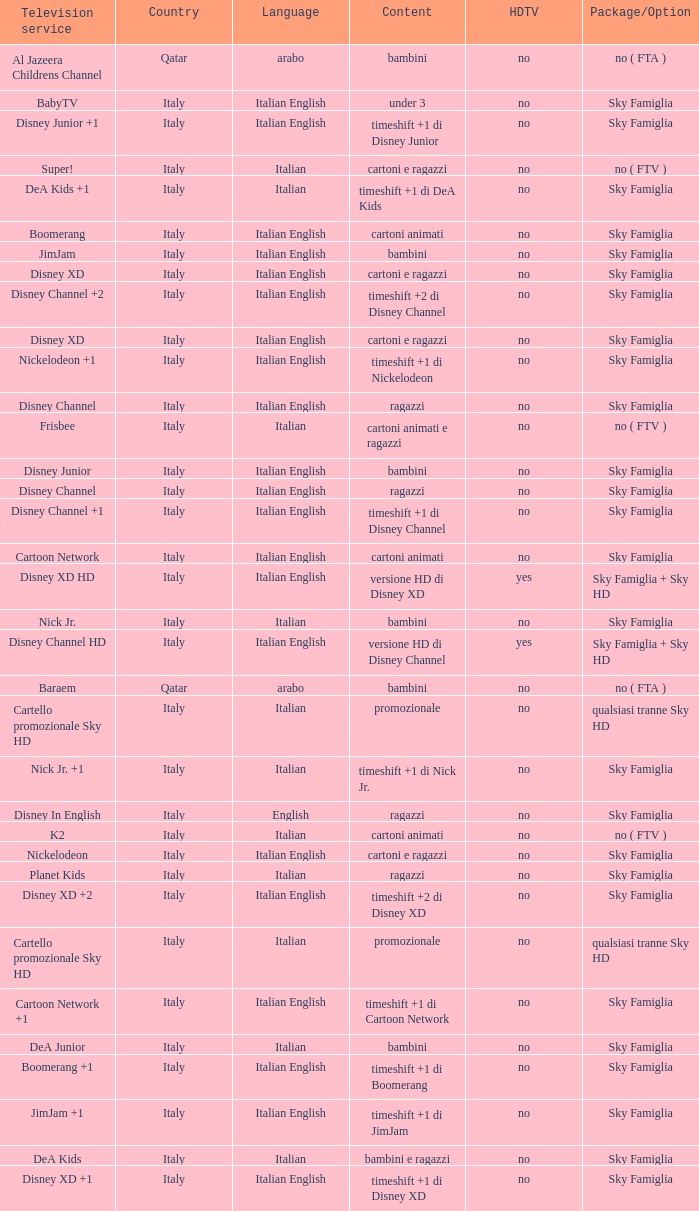What shows as Content for the Television service of nickelodeon +1? Timeshift +1 di nickelodeon. 